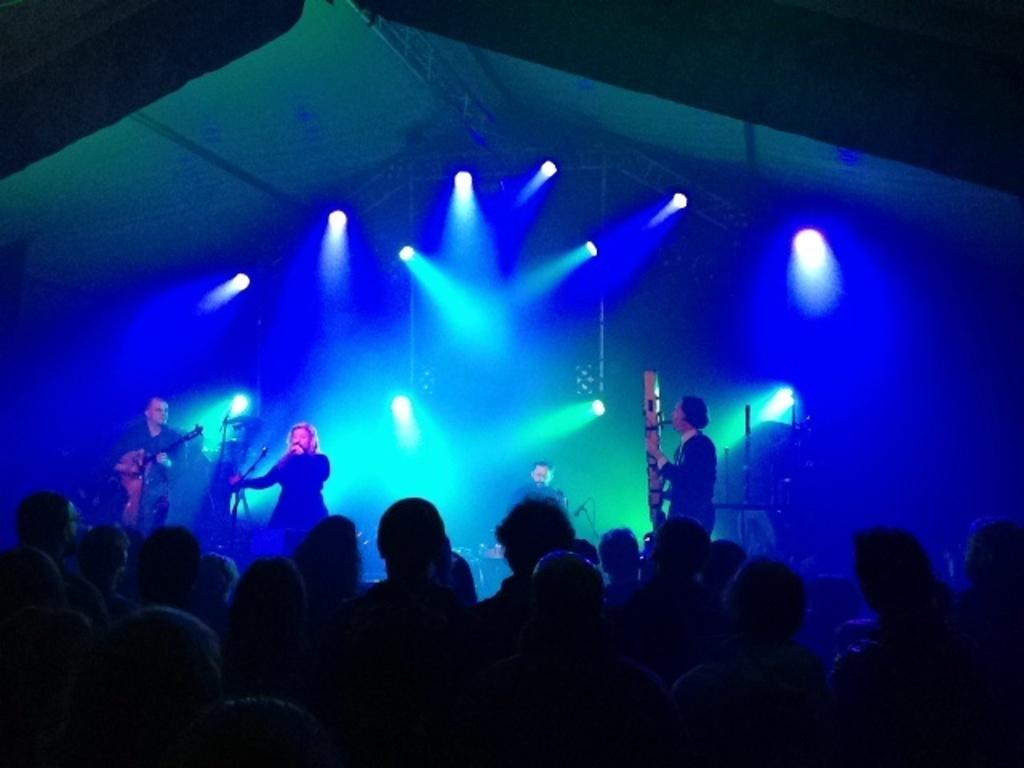What is happening in the image? There are people standing in the image, some of whom are on a stage. What are the people on the stage doing? The people on the stage are holding music instruments. Can you describe the lighting in the image? There are lights visible in the image. How many trees can be seen in the image? There are no trees present in the image. What type of breath do the people on the stage have? There is no information about the people's breath in the image. 